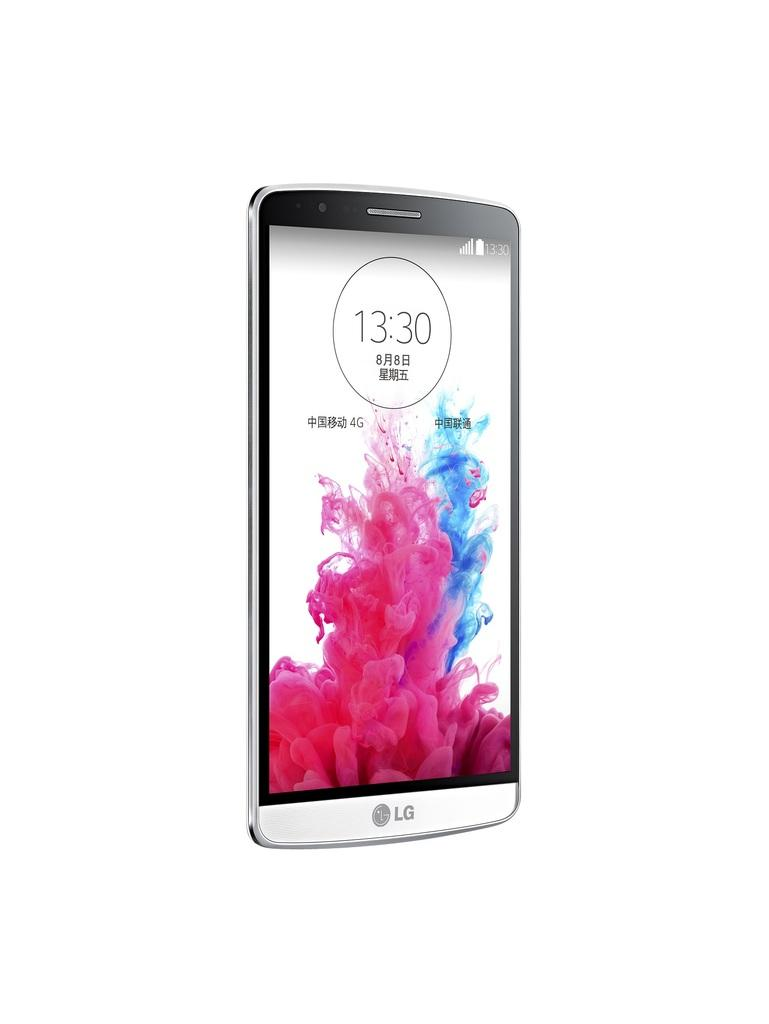<image>
Relay a brief, clear account of the picture shown. An LG phone with the time displayed as 13:30. 